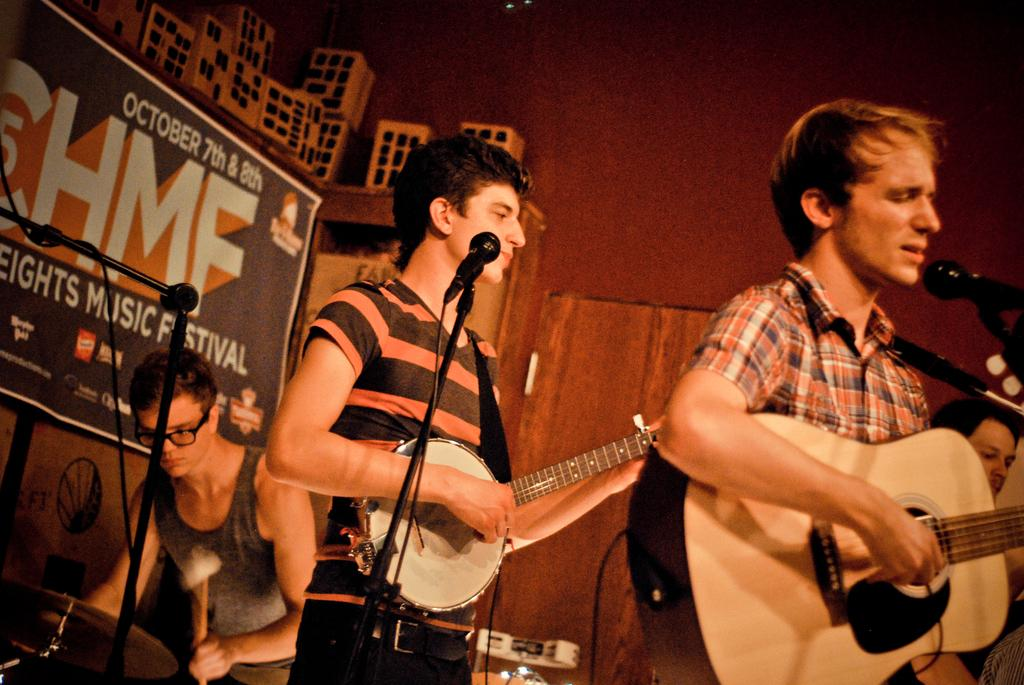What is happening in the image involving people? There are people on stage in the image. What can be seen hanging or displayed in the image? There is a banner in the image. What is the color of the wall visible in the image? There is a red color wall in the image. What is the person on stage doing? A person is singing on a microphone. What instrument is the person singing holding? The person singing is holding a guitar in their hand. How does the earthquake affect the stage and performers in the image? There is no earthquake present in the image; it only shows people on stage, a banner, a red wall, a person singing on a microphone, and a guitar. What type of cloth is draped over the guitar in the image? There is no cloth present on the guitar in the image; it is simply held by the person singing. 